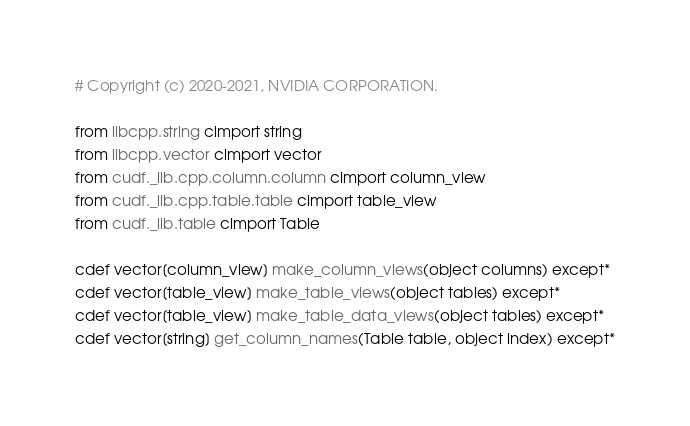Convert code to text. <code><loc_0><loc_0><loc_500><loc_500><_Cython_># Copyright (c) 2020-2021, NVIDIA CORPORATION.

from libcpp.string cimport string
from libcpp.vector cimport vector
from cudf._lib.cpp.column.column cimport column_view
from cudf._lib.cpp.table.table cimport table_view
from cudf._lib.table cimport Table

cdef vector[column_view] make_column_views(object columns) except*
cdef vector[table_view] make_table_views(object tables) except*
cdef vector[table_view] make_table_data_views(object tables) except*
cdef vector[string] get_column_names(Table table, object index) except*
</code> 